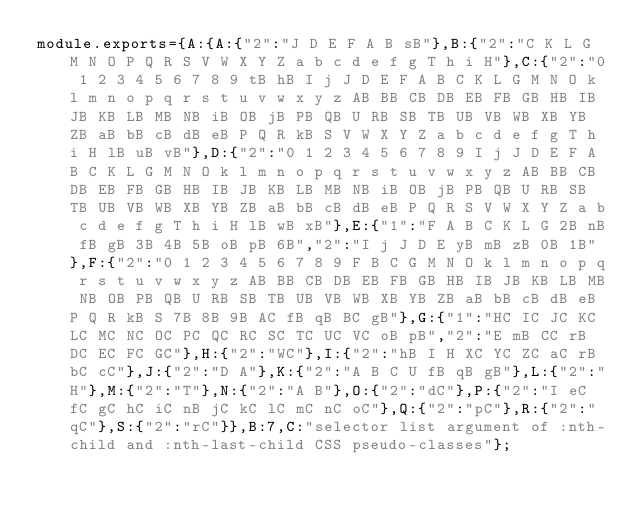Convert code to text. <code><loc_0><loc_0><loc_500><loc_500><_JavaScript_>module.exports={A:{A:{"2":"J D E F A B sB"},B:{"2":"C K L G M N O P Q R S V W X Y Z a b c d e f g T h i H"},C:{"2":"0 1 2 3 4 5 6 7 8 9 tB hB I j J D E F A B C K L G M N O k l m n o p q r s t u v w x y z AB BB CB DB EB FB GB HB IB JB KB LB MB NB iB OB jB PB QB U RB SB TB UB VB WB XB YB ZB aB bB cB dB eB P Q R kB S V W X Y Z a b c d e f g T h i H lB uB vB"},D:{"2":"0 1 2 3 4 5 6 7 8 9 I j J D E F A B C K L G M N O k l m n o p q r s t u v w x y z AB BB CB DB EB FB GB HB IB JB KB LB MB NB iB OB jB PB QB U RB SB TB UB VB WB XB YB ZB aB bB cB dB eB P Q R S V W X Y Z a b c d e f g T h i H lB wB xB"},E:{"1":"F A B C K L G 2B nB fB gB 3B 4B 5B oB pB 6B","2":"I j J D E yB mB zB 0B 1B"},F:{"2":"0 1 2 3 4 5 6 7 8 9 F B C G M N O k l m n o p q r s t u v w x y z AB BB CB DB EB FB GB HB IB JB KB LB MB NB OB PB QB U RB SB TB UB VB WB XB YB ZB aB bB cB dB eB P Q R kB S 7B 8B 9B AC fB qB BC gB"},G:{"1":"HC IC JC KC LC MC NC OC PC QC RC SC TC UC VC oB pB","2":"E mB CC rB DC EC FC GC"},H:{"2":"WC"},I:{"2":"hB I H XC YC ZC aC rB bC cC"},J:{"2":"D A"},K:{"2":"A B C U fB qB gB"},L:{"2":"H"},M:{"2":"T"},N:{"2":"A B"},O:{"2":"dC"},P:{"2":"I eC fC gC hC iC nB jC kC lC mC nC oC"},Q:{"2":"pC"},R:{"2":"qC"},S:{"2":"rC"}},B:7,C:"selector list argument of :nth-child and :nth-last-child CSS pseudo-classes"};
</code> 